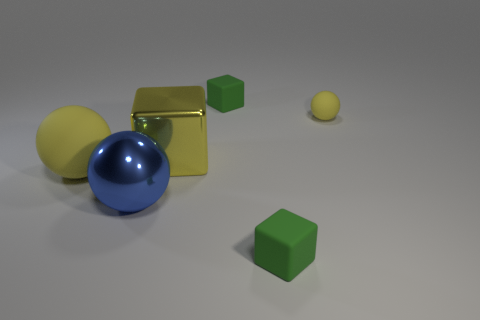Do the large matte ball and the tiny matte ball have the same color?
Keep it short and to the point. Yes. How many big objects are the same material as the tiny yellow sphere?
Ensure brevity in your answer.  1. There is a blue metal object that is the same shape as the small yellow rubber object; what size is it?
Keep it short and to the point. Large. What is the material of the large blue sphere?
Your response must be concise. Metal. What material is the blue ball that is in front of the large sphere behind the blue sphere that is in front of the big yellow matte ball?
Keep it short and to the point. Metal. Is there anything else that is the same shape as the large blue shiny object?
Make the answer very short. Yes. The tiny thing that is the same shape as the large blue thing is what color?
Provide a short and direct response. Yellow. There is a big ball that is on the left side of the big blue thing; does it have the same color as the small sphere that is to the right of the yellow block?
Provide a succinct answer. Yes. Are there more green blocks that are in front of the yellow shiny block than tiny brown shiny blocks?
Provide a succinct answer. Yes. What number of large balls are on the left side of the big blue sphere and in front of the large yellow sphere?
Offer a terse response. 0. 